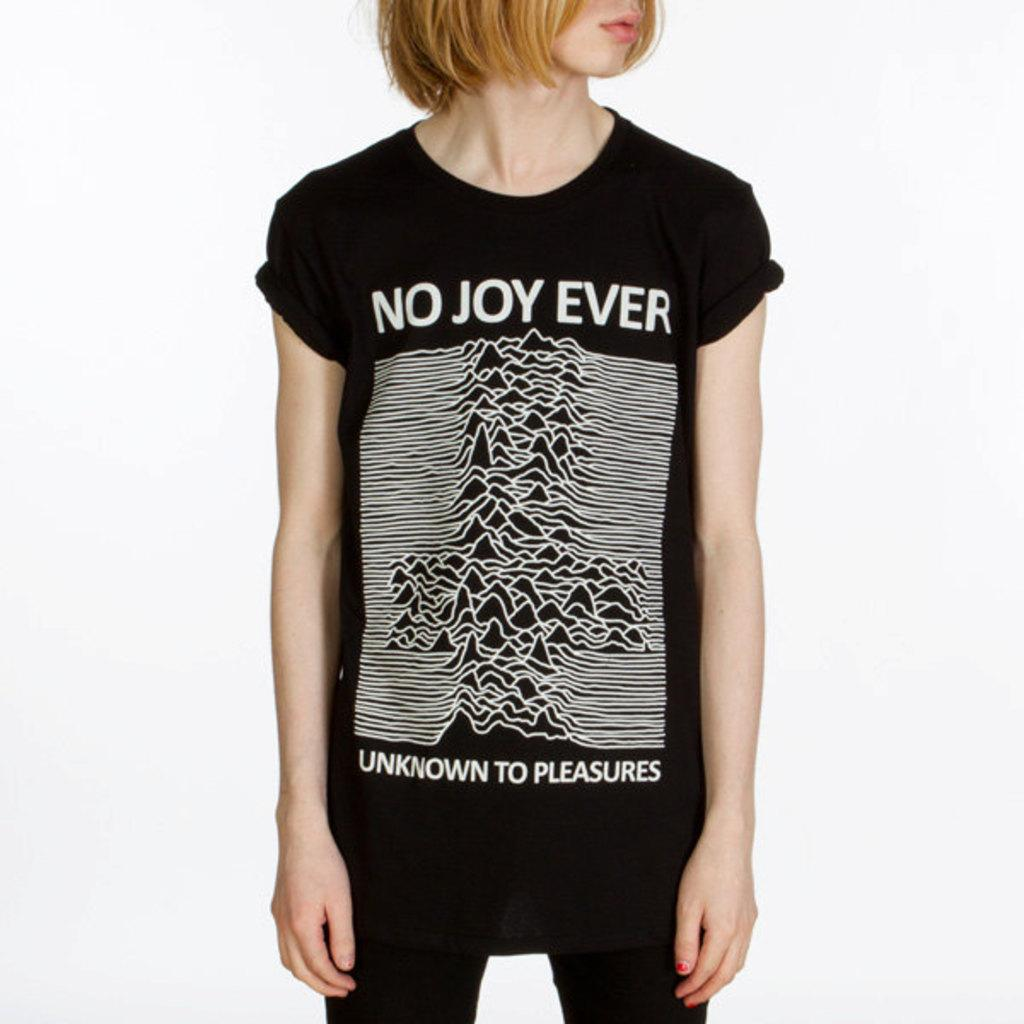Who or what is the main subject of the image? There is a person in the image. What is the person wearing? The person is wearing a black dress. What color is the background of the image? The background of the image is white. What type of oatmeal is being served on the tray in the image? There is no tray or oatmeal present in the image. 